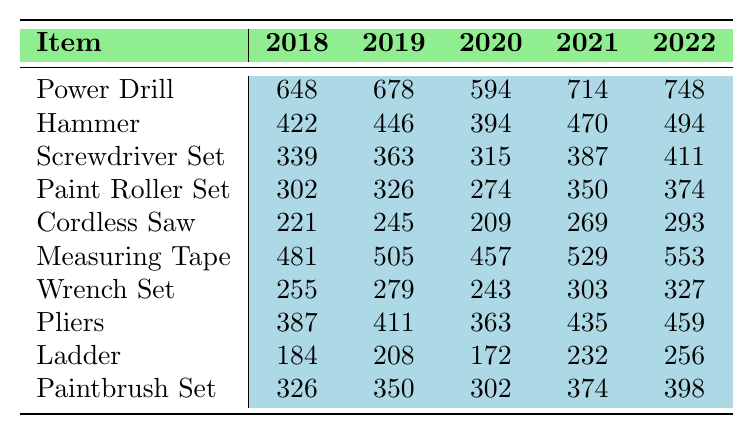What was the total sales for the Power Drill in 2021? The sales figures for the Power Drill in 2021 are provided as monthly sales data. Summing these values (48 + 45 + 52 + 58 + 65 + 70 + 75 + 72 + 60 + 55 + 52 + 62) gives a total of 714.
Answer: 714 Which item had the highest total sales in 2022? By examining the total sales for each item in 2022, the Power Drill has the highest sales of 748, compared to the next highest, which is the Measuring Tape at 553.
Answer: Power Drill What is the difference in total sales for the Hammer between 2018 and 2022? The total sales for the Hammer in 2018 is 422, and in 2022 it is 494. The difference is calculated as 494 - 422 = 72.
Answer: 72 What was the average monthly sales for the Screwdriver Set over the five years? To find the average, sum the monthly sales for the Screwdriver Set across all five years (339 + 363 + 315 + 387 + 411 = 1815) and divide by the number of years multiplied by 12 (1815 / 60 = 30.25).
Answer: 30.25 Did the sales for the Cordless Saw increase every year from 2018 to 2022? By examining the total sales for Cordless Saw: 221 in 2018, 245 in 2019, 209 in 2020, 269 in 2021, and 293 in 2022, we see that sales decreased from 2019 to 2020, so it did not increase every year.
Answer: No Which item had the lowest total sales in 2020? By comparing total sales for each item in 2020, the Ladder has the lowest sales of 172. Thus, it had the lowest total.
Answer: Ladder How much did total sales for the Paintbrush Set increase from 2018 to 2022? The total sales for the Paintbrush Set in 2018 was 326, and in 2022 it was 398. The increase is calculated as 398 - 326 = 72.
Answer: 72 What was the total sales for all items combined in 2019? We sum the total sales for each item for 2019 (678 + 446 + 363 + 326 + 245 + 505 + 279 + 411 + 208 + 350 = 3644) to get the total combined sales for that year.
Answer: 3644 Which two items had the closest total sales in 2021? The Wrench Set had total sales of 303 and the Pliers had total sales of 435, with a difference of 132. The closest pair is Hammer (470) and Paint Roller Set (350), which have a difference of 120.
Answer: Hammer and Paint Roller Set What trend can be observed in the sales of the Measuring Tape from 2018 to 2022? Reviewing the trends, the sales figures show a consistent increase each year: from 481 in 2018 to 553 in 2022, indicating a positive upward trend.
Answer: Positive upward trend What was the sales figure for the Ladder in 2020? The table indicates that the sales figure for the Ladder in 2020 is 172.
Answer: 172 